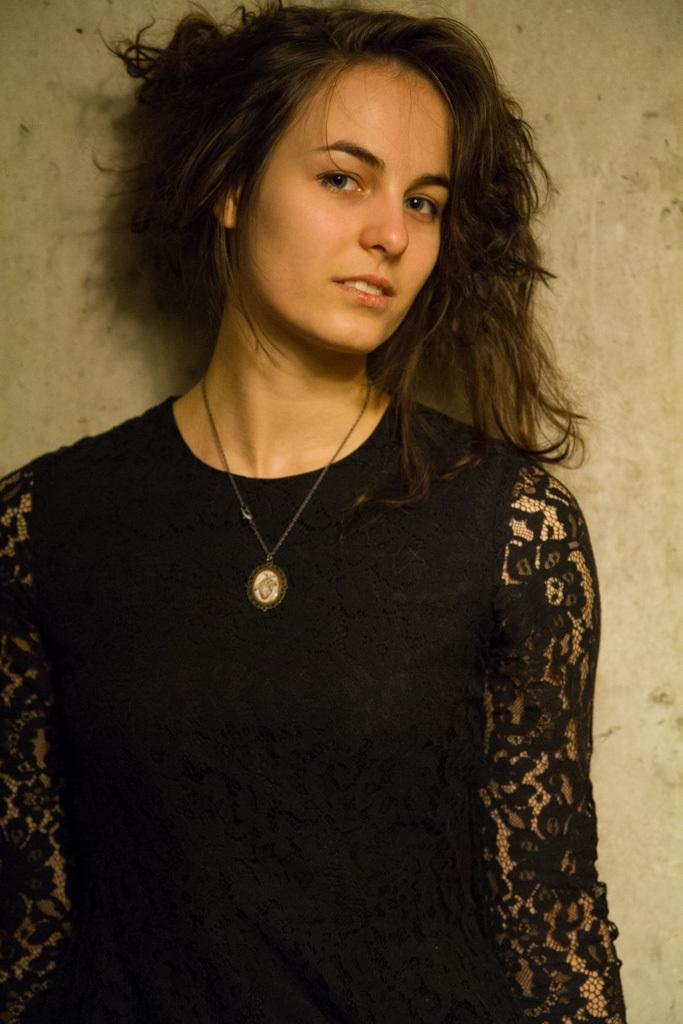What is the main subject of the image? There is a person standing in the image. What can be seen behind the person? There is a wall visible behind the person. How many people are in the crowd at the park in the image? There is no crowd or park present in the image; it only features a person standing in front of a wall. 